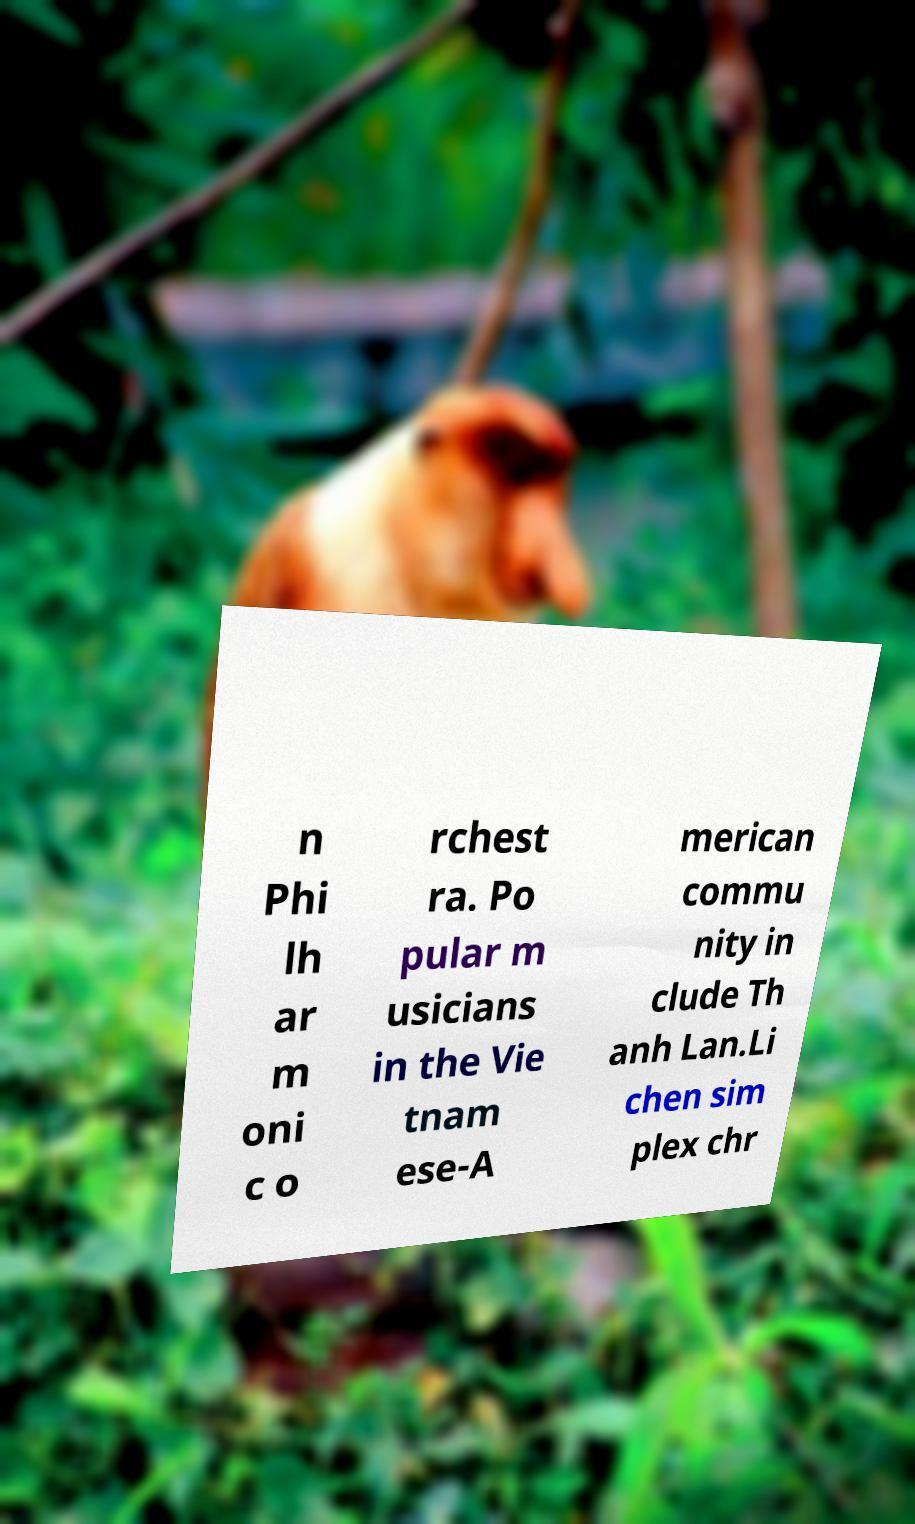Can you accurately transcribe the text from the provided image for me? n Phi lh ar m oni c o rchest ra. Po pular m usicians in the Vie tnam ese-A merican commu nity in clude Th anh Lan.Li chen sim plex chr 